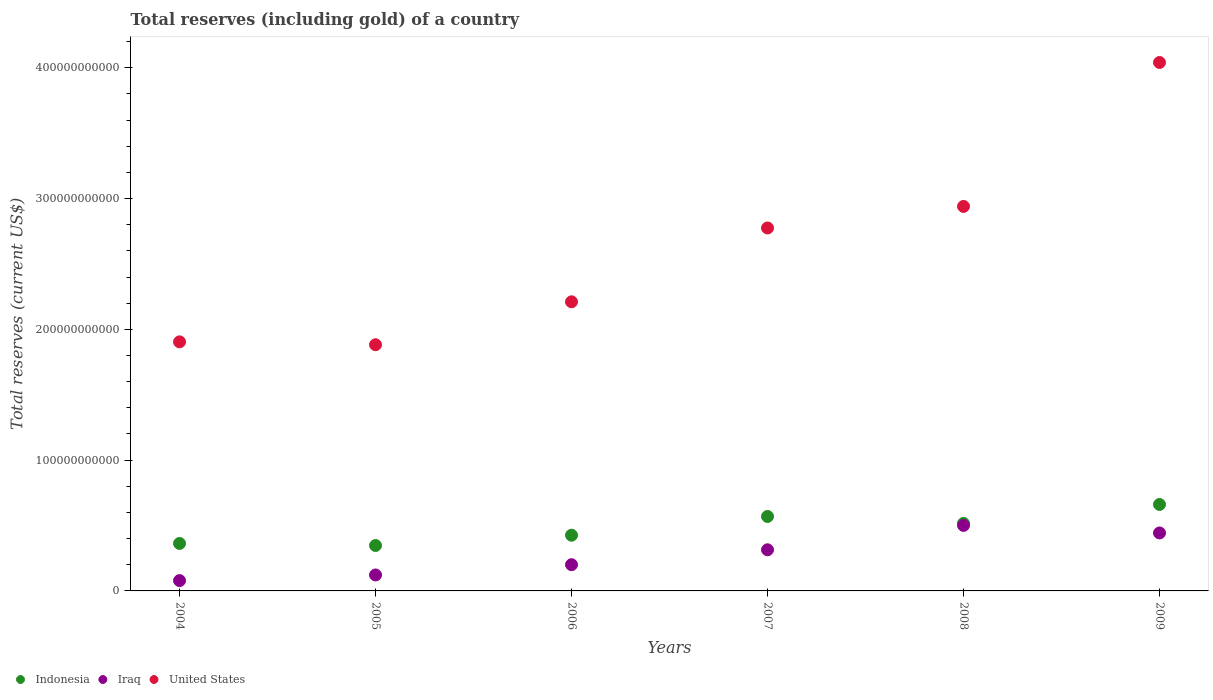Is the number of dotlines equal to the number of legend labels?
Provide a short and direct response. Yes. What is the total reserves (including gold) in Iraq in 2009?
Provide a short and direct response. 4.43e+1. Across all years, what is the maximum total reserves (including gold) in Indonesia?
Provide a succinct answer. 6.61e+1. Across all years, what is the minimum total reserves (including gold) in Indonesia?
Provide a succinct answer. 3.47e+1. What is the total total reserves (including gold) in Iraq in the graph?
Ensure brevity in your answer.  1.66e+11. What is the difference between the total reserves (including gold) in Iraq in 2005 and that in 2007?
Your response must be concise. -1.93e+1. What is the difference between the total reserves (including gold) in Iraq in 2004 and the total reserves (including gold) in United States in 2007?
Offer a terse response. -2.70e+11. What is the average total reserves (including gold) in United States per year?
Provide a short and direct response. 2.63e+11. In the year 2006, what is the difference between the total reserves (including gold) in United States and total reserves (including gold) in Indonesia?
Offer a very short reply. 1.78e+11. What is the ratio of the total reserves (including gold) in United States in 2006 to that in 2008?
Your answer should be compact. 0.75. Is the total reserves (including gold) in Iraq in 2006 less than that in 2008?
Provide a succinct answer. Yes. Is the difference between the total reserves (including gold) in United States in 2004 and 2008 greater than the difference between the total reserves (including gold) in Indonesia in 2004 and 2008?
Your answer should be very brief. No. What is the difference between the highest and the second highest total reserves (including gold) in Indonesia?
Offer a terse response. 9.18e+09. What is the difference between the highest and the lowest total reserves (including gold) in Indonesia?
Your answer should be compact. 3.14e+1. How many dotlines are there?
Your answer should be very brief. 3. What is the difference between two consecutive major ticks on the Y-axis?
Provide a succinct answer. 1.00e+11. Are the values on the major ticks of Y-axis written in scientific E-notation?
Offer a very short reply. No. Does the graph contain grids?
Provide a short and direct response. No. How many legend labels are there?
Provide a short and direct response. 3. How are the legend labels stacked?
Your response must be concise. Horizontal. What is the title of the graph?
Make the answer very short. Total reserves (including gold) of a country. Does "High income: nonOECD" appear as one of the legend labels in the graph?
Offer a terse response. No. What is the label or title of the Y-axis?
Ensure brevity in your answer.  Total reserves (current US$). What is the Total reserves (current US$) in Indonesia in 2004?
Your answer should be compact. 3.63e+1. What is the Total reserves (current US$) in Iraq in 2004?
Ensure brevity in your answer.  7.91e+09. What is the Total reserves (current US$) of United States in 2004?
Offer a terse response. 1.90e+11. What is the Total reserves (current US$) in Indonesia in 2005?
Your answer should be compact. 3.47e+1. What is the Total reserves (current US$) in Iraq in 2005?
Your response must be concise. 1.22e+1. What is the Total reserves (current US$) of United States in 2005?
Keep it short and to the point. 1.88e+11. What is the Total reserves (current US$) of Indonesia in 2006?
Your answer should be very brief. 4.26e+1. What is the Total reserves (current US$) in Iraq in 2006?
Your answer should be compact. 2.01e+1. What is the Total reserves (current US$) in United States in 2006?
Give a very brief answer. 2.21e+11. What is the Total reserves (current US$) in Indonesia in 2007?
Your answer should be compact. 5.69e+1. What is the Total reserves (current US$) in Iraq in 2007?
Provide a succinct answer. 3.15e+1. What is the Total reserves (current US$) in United States in 2007?
Your answer should be compact. 2.78e+11. What is the Total reserves (current US$) of Indonesia in 2008?
Keep it short and to the point. 5.16e+1. What is the Total reserves (current US$) in Iraq in 2008?
Your answer should be very brief. 5.01e+1. What is the Total reserves (current US$) in United States in 2008?
Your answer should be very brief. 2.94e+11. What is the Total reserves (current US$) of Indonesia in 2009?
Provide a succinct answer. 6.61e+1. What is the Total reserves (current US$) of Iraq in 2009?
Keep it short and to the point. 4.43e+1. What is the Total reserves (current US$) of United States in 2009?
Your answer should be very brief. 4.04e+11. Across all years, what is the maximum Total reserves (current US$) in Indonesia?
Your answer should be compact. 6.61e+1. Across all years, what is the maximum Total reserves (current US$) in Iraq?
Your answer should be compact. 5.01e+1. Across all years, what is the maximum Total reserves (current US$) of United States?
Your response must be concise. 4.04e+11. Across all years, what is the minimum Total reserves (current US$) of Indonesia?
Make the answer very short. 3.47e+1. Across all years, what is the minimum Total reserves (current US$) in Iraq?
Make the answer very short. 7.91e+09. Across all years, what is the minimum Total reserves (current US$) of United States?
Your answer should be compact. 1.88e+11. What is the total Total reserves (current US$) in Indonesia in the graph?
Your response must be concise. 2.88e+11. What is the total Total reserves (current US$) in Iraq in the graph?
Your answer should be very brief. 1.66e+11. What is the total Total reserves (current US$) in United States in the graph?
Keep it short and to the point. 1.58e+12. What is the difference between the Total reserves (current US$) of Indonesia in 2004 and that in 2005?
Your answer should be very brief. 1.58e+09. What is the difference between the Total reserves (current US$) in Iraq in 2004 and that in 2005?
Your response must be concise. -4.29e+09. What is the difference between the Total reserves (current US$) in United States in 2004 and that in 2005?
Provide a succinct answer. 2.21e+09. What is the difference between the Total reserves (current US$) of Indonesia in 2004 and that in 2006?
Give a very brief answer. -6.29e+09. What is the difference between the Total reserves (current US$) of Iraq in 2004 and that in 2006?
Make the answer very short. -1.21e+1. What is the difference between the Total reserves (current US$) of United States in 2004 and that in 2006?
Your response must be concise. -3.06e+1. What is the difference between the Total reserves (current US$) of Indonesia in 2004 and that in 2007?
Your response must be concise. -2.06e+1. What is the difference between the Total reserves (current US$) in Iraq in 2004 and that in 2007?
Your answer should be compact. -2.35e+1. What is the difference between the Total reserves (current US$) of United States in 2004 and that in 2007?
Provide a short and direct response. -8.71e+1. What is the difference between the Total reserves (current US$) of Indonesia in 2004 and that in 2008?
Your response must be concise. -1.53e+1. What is the difference between the Total reserves (current US$) in Iraq in 2004 and that in 2008?
Keep it short and to the point. -4.22e+1. What is the difference between the Total reserves (current US$) of United States in 2004 and that in 2008?
Provide a succinct answer. -1.04e+11. What is the difference between the Total reserves (current US$) of Indonesia in 2004 and that in 2009?
Your response must be concise. -2.98e+1. What is the difference between the Total reserves (current US$) of Iraq in 2004 and that in 2009?
Provide a succinct answer. -3.64e+1. What is the difference between the Total reserves (current US$) of United States in 2004 and that in 2009?
Provide a succinct answer. -2.14e+11. What is the difference between the Total reserves (current US$) in Indonesia in 2005 and that in 2006?
Provide a short and direct response. -7.87e+09. What is the difference between the Total reserves (current US$) of Iraq in 2005 and that in 2006?
Provide a succinct answer. -7.85e+09. What is the difference between the Total reserves (current US$) in United States in 2005 and that in 2006?
Make the answer very short. -3.28e+1. What is the difference between the Total reserves (current US$) of Indonesia in 2005 and that in 2007?
Offer a terse response. -2.22e+1. What is the difference between the Total reserves (current US$) in Iraq in 2005 and that in 2007?
Offer a terse response. -1.93e+1. What is the difference between the Total reserves (current US$) in United States in 2005 and that in 2007?
Give a very brief answer. -8.93e+1. What is the difference between the Total reserves (current US$) in Indonesia in 2005 and that in 2008?
Ensure brevity in your answer.  -1.69e+1. What is the difference between the Total reserves (current US$) of Iraq in 2005 and that in 2008?
Provide a succinct answer. -3.79e+1. What is the difference between the Total reserves (current US$) of United States in 2005 and that in 2008?
Ensure brevity in your answer.  -1.06e+11. What is the difference between the Total reserves (current US$) in Indonesia in 2005 and that in 2009?
Provide a succinct answer. -3.14e+1. What is the difference between the Total reserves (current US$) of Iraq in 2005 and that in 2009?
Your answer should be very brief. -3.21e+1. What is the difference between the Total reserves (current US$) of United States in 2005 and that in 2009?
Your response must be concise. -2.16e+11. What is the difference between the Total reserves (current US$) of Indonesia in 2006 and that in 2007?
Your answer should be compact. -1.43e+1. What is the difference between the Total reserves (current US$) of Iraq in 2006 and that in 2007?
Provide a succinct answer. -1.14e+1. What is the difference between the Total reserves (current US$) in United States in 2006 and that in 2007?
Your response must be concise. -5.65e+1. What is the difference between the Total reserves (current US$) in Indonesia in 2006 and that in 2008?
Provide a short and direct response. -9.04e+09. What is the difference between the Total reserves (current US$) of Iraq in 2006 and that in 2008?
Keep it short and to the point. -3.01e+1. What is the difference between the Total reserves (current US$) of United States in 2006 and that in 2008?
Your answer should be compact. -7.30e+1. What is the difference between the Total reserves (current US$) of Indonesia in 2006 and that in 2009?
Offer a very short reply. -2.35e+1. What is the difference between the Total reserves (current US$) in Iraq in 2006 and that in 2009?
Keep it short and to the point. -2.43e+1. What is the difference between the Total reserves (current US$) in United States in 2006 and that in 2009?
Keep it short and to the point. -1.83e+11. What is the difference between the Total reserves (current US$) in Indonesia in 2007 and that in 2008?
Ensure brevity in your answer.  5.30e+09. What is the difference between the Total reserves (current US$) of Iraq in 2007 and that in 2008?
Your answer should be compact. -1.86e+1. What is the difference between the Total reserves (current US$) of United States in 2007 and that in 2008?
Offer a terse response. -1.65e+1. What is the difference between the Total reserves (current US$) in Indonesia in 2007 and that in 2009?
Provide a succinct answer. -9.18e+09. What is the difference between the Total reserves (current US$) of Iraq in 2007 and that in 2009?
Keep it short and to the point. -1.29e+1. What is the difference between the Total reserves (current US$) of United States in 2007 and that in 2009?
Offer a very short reply. -1.27e+11. What is the difference between the Total reserves (current US$) of Indonesia in 2008 and that in 2009?
Your answer should be compact. -1.45e+1. What is the difference between the Total reserves (current US$) in Iraq in 2008 and that in 2009?
Offer a very short reply. 5.77e+09. What is the difference between the Total reserves (current US$) in United States in 2008 and that in 2009?
Keep it short and to the point. -1.10e+11. What is the difference between the Total reserves (current US$) in Indonesia in 2004 and the Total reserves (current US$) in Iraq in 2005?
Ensure brevity in your answer.  2.41e+1. What is the difference between the Total reserves (current US$) in Indonesia in 2004 and the Total reserves (current US$) in United States in 2005?
Offer a terse response. -1.52e+11. What is the difference between the Total reserves (current US$) in Iraq in 2004 and the Total reserves (current US$) in United States in 2005?
Ensure brevity in your answer.  -1.80e+11. What is the difference between the Total reserves (current US$) in Indonesia in 2004 and the Total reserves (current US$) in Iraq in 2006?
Ensure brevity in your answer.  1.63e+1. What is the difference between the Total reserves (current US$) in Indonesia in 2004 and the Total reserves (current US$) in United States in 2006?
Your response must be concise. -1.85e+11. What is the difference between the Total reserves (current US$) in Iraq in 2004 and the Total reserves (current US$) in United States in 2006?
Provide a succinct answer. -2.13e+11. What is the difference between the Total reserves (current US$) of Indonesia in 2004 and the Total reserves (current US$) of Iraq in 2007?
Keep it short and to the point. 4.86e+09. What is the difference between the Total reserves (current US$) of Indonesia in 2004 and the Total reserves (current US$) of United States in 2007?
Provide a short and direct response. -2.41e+11. What is the difference between the Total reserves (current US$) in Iraq in 2004 and the Total reserves (current US$) in United States in 2007?
Your response must be concise. -2.70e+11. What is the difference between the Total reserves (current US$) in Indonesia in 2004 and the Total reserves (current US$) in Iraq in 2008?
Ensure brevity in your answer.  -1.38e+1. What is the difference between the Total reserves (current US$) of Indonesia in 2004 and the Total reserves (current US$) of United States in 2008?
Make the answer very short. -2.58e+11. What is the difference between the Total reserves (current US$) in Iraq in 2004 and the Total reserves (current US$) in United States in 2008?
Provide a succinct answer. -2.86e+11. What is the difference between the Total reserves (current US$) of Indonesia in 2004 and the Total reserves (current US$) of Iraq in 2009?
Your response must be concise. -8.02e+09. What is the difference between the Total reserves (current US$) of Indonesia in 2004 and the Total reserves (current US$) of United States in 2009?
Make the answer very short. -3.68e+11. What is the difference between the Total reserves (current US$) in Iraq in 2004 and the Total reserves (current US$) in United States in 2009?
Your response must be concise. -3.96e+11. What is the difference between the Total reserves (current US$) of Indonesia in 2005 and the Total reserves (current US$) of Iraq in 2006?
Give a very brief answer. 1.47e+1. What is the difference between the Total reserves (current US$) of Indonesia in 2005 and the Total reserves (current US$) of United States in 2006?
Offer a terse response. -1.86e+11. What is the difference between the Total reserves (current US$) of Iraq in 2005 and the Total reserves (current US$) of United States in 2006?
Give a very brief answer. -2.09e+11. What is the difference between the Total reserves (current US$) of Indonesia in 2005 and the Total reserves (current US$) of Iraq in 2007?
Provide a short and direct response. 3.28e+09. What is the difference between the Total reserves (current US$) of Indonesia in 2005 and the Total reserves (current US$) of United States in 2007?
Give a very brief answer. -2.43e+11. What is the difference between the Total reserves (current US$) in Iraq in 2005 and the Total reserves (current US$) in United States in 2007?
Make the answer very short. -2.65e+11. What is the difference between the Total reserves (current US$) in Indonesia in 2005 and the Total reserves (current US$) in Iraq in 2008?
Make the answer very short. -1.54e+1. What is the difference between the Total reserves (current US$) in Indonesia in 2005 and the Total reserves (current US$) in United States in 2008?
Your response must be concise. -2.59e+11. What is the difference between the Total reserves (current US$) in Iraq in 2005 and the Total reserves (current US$) in United States in 2008?
Give a very brief answer. -2.82e+11. What is the difference between the Total reserves (current US$) in Indonesia in 2005 and the Total reserves (current US$) in Iraq in 2009?
Keep it short and to the point. -9.60e+09. What is the difference between the Total reserves (current US$) of Indonesia in 2005 and the Total reserves (current US$) of United States in 2009?
Your answer should be compact. -3.69e+11. What is the difference between the Total reserves (current US$) in Iraq in 2005 and the Total reserves (current US$) in United States in 2009?
Offer a terse response. -3.92e+11. What is the difference between the Total reserves (current US$) of Indonesia in 2006 and the Total reserves (current US$) of Iraq in 2007?
Offer a very short reply. 1.11e+1. What is the difference between the Total reserves (current US$) of Indonesia in 2006 and the Total reserves (current US$) of United States in 2007?
Offer a very short reply. -2.35e+11. What is the difference between the Total reserves (current US$) of Iraq in 2006 and the Total reserves (current US$) of United States in 2007?
Provide a succinct answer. -2.57e+11. What is the difference between the Total reserves (current US$) in Indonesia in 2006 and the Total reserves (current US$) in Iraq in 2008?
Ensure brevity in your answer.  -7.50e+09. What is the difference between the Total reserves (current US$) of Indonesia in 2006 and the Total reserves (current US$) of United States in 2008?
Provide a succinct answer. -2.51e+11. What is the difference between the Total reserves (current US$) of Iraq in 2006 and the Total reserves (current US$) of United States in 2008?
Make the answer very short. -2.74e+11. What is the difference between the Total reserves (current US$) of Indonesia in 2006 and the Total reserves (current US$) of Iraq in 2009?
Ensure brevity in your answer.  -1.74e+09. What is the difference between the Total reserves (current US$) in Indonesia in 2006 and the Total reserves (current US$) in United States in 2009?
Your answer should be compact. -3.62e+11. What is the difference between the Total reserves (current US$) in Iraq in 2006 and the Total reserves (current US$) in United States in 2009?
Your answer should be very brief. -3.84e+11. What is the difference between the Total reserves (current US$) of Indonesia in 2007 and the Total reserves (current US$) of Iraq in 2008?
Keep it short and to the point. 6.83e+09. What is the difference between the Total reserves (current US$) of Indonesia in 2007 and the Total reserves (current US$) of United States in 2008?
Your answer should be very brief. -2.37e+11. What is the difference between the Total reserves (current US$) in Iraq in 2007 and the Total reserves (current US$) in United States in 2008?
Your answer should be compact. -2.63e+11. What is the difference between the Total reserves (current US$) of Indonesia in 2007 and the Total reserves (current US$) of Iraq in 2009?
Your answer should be very brief. 1.26e+1. What is the difference between the Total reserves (current US$) in Indonesia in 2007 and the Total reserves (current US$) in United States in 2009?
Ensure brevity in your answer.  -3.47e+11. What is the difference between the Total reserves (current US$) of Iraq in 2007 and the Total reserves (current US$) of United States in 2009?
Offer a very short reply. -3.73e+11. What is the difference between the Total reserves (current US$) of Indonesia in 2008 and the Total reserves (current US$) of Iraq in 2009?
Provide a succinct answer. 7.31e+09. What is the difference between the Total reserves (current US$) of Indonesia in 2008 and the Total reserves (current US$) of United States in 2009?
Your answer should be compact. -3.52e+11. What is the difference between the Total reserves (current US$) of Iraq in 2008 and the Total reserves (current US$) of United States in 2009?
Your response must be concise. -3.54e+11. What is the average Total reserves (current US$) in Indonesia per year?
Ensure brevity in your answer.  4.81e+1. What is the average Total reserves (current US$) in Iraq per year?
Give a very brief answer. 2.77e+1. What is the average Total reserves (current US$) of United States per year?
Offer a terse response. 2.63e+11. In the year 2004, what is the difference between the Total reserves (current US$) of Indonesia and Total reserves (current US$) of Iraq?
Offer a terse response. 2.84e+1. In the year 2004, what is the difference between the Total reserves (current US$) in Indonesia and Total reserves (current US$) in United States?
Keep it short and to the point. -1.54e+11. In the year 2004, what is the difference between the Total reserves (current US$) in Iraq and Total reserves (current US$) in United States?
Make the answer very short. -1.83e+11. In the year 2005, what is the difference between the Total reserves (current US$) in Indonesia and Total reserves (current US$) in Iraq?
Your answer should be very brief. 2.25e+1. In the year 2005, what is the difference between the Total reserves (current US$) of Indonesia and Total reserves (current US$) of United States?
Provide a short and direct response. -1.54e+11. In the year 2005, what is the difference between the Total reserves (current US$) in Iraq and Total reserves (current US$) in United States?
Make the answer very short. -1.76e+11. In the year 2006, what is the difference between the Total reserves (current US$) of Indonesia and Total reserves (current US$) of Iraq?
Give a very brief answer. 2.25e+1. In the year 2006, what is the difference between the Total reserves (current US$) in Indonesia and Total reserves (current US$) in United States?
Ensure brevity in your answer.  -1.78e+11. In the year 2006, what is the difference between the Total reserves (current US$) of Iraq and Total reserves (current US$) of United States?
Make the answer very short. -2.01e+11. In the year 2007, what is the difference between the Total reserves (current US$) in Indonesia and Total reserves (current US$) in Iraq?
Your answer should be very brief. 2.55e+1. In the year 2007, what is the difference between the Total reserves (current US$) of Indonesia and Total reserves (current US$) of United States?
Provide a succinct answer. -2.21e+11. In the year 2007, what is the difference between the Total reserves (current US$) in Iraq and Total reserves (current US$) in United States?
Give a very brief answer. -2.46e+11. In the year 2008, what is the difference between the Total reserves (current US$) in Indonesia and Total reserves (current US$) in Iraq?
Your answer should be very brief. 1.54e+09. In the year 2008, what is the difference between the Total reserves (current US$) of Indonesia and Total reserves (current US$) of United States?
Give a very brief answer. -2.42e+11. In the year 2008, what is the difference between the Total reserves (current US$) of Iraq and Total reserves (current US$) of United States?
Provide a succinct answer. -2.44e+11. In the year 2009, what is the difference between the Total reserves (current US$) in Indonesia and Total reserves (current US$) in Iraq?
Your answer should be very brief. 2.18e+1. In the year 2009, what is the difference between the Total reserves (current US$) in Indonesia and Total reserves (current US$) in United States?
Ensure brevity in your answer.  -3.38e+11. In the year 2009, what is the difference between the Total reserves (current US$) of Iraq and Total reserves (current US$) of United States?
Keep it short and to the point. -3.60e+11. What is the ratio of the Total reserves (current US$) in Indonesia in 2004 to that in 2005?
Your answer should be compact. 1.05. What is the ratio of the Total reserves (current US$) of Iraq in 2004 to that in 2005?
Give a very brief answer. 0.65. What is the ratio of the Total reserves (current US$) of United States in 2004 to that in 2005?
Your answer should be very brief. 1.01. What is the ratio of the Total reserves (current US$) in Indonesia in 2004 to that in 2006?
Make the answer very short. 0.85. What is the ratio of the Total reserves (current US$) of Iraq in 2004 to that in 2006?
Your response must be concise. 0.39. What is the ratio of the Total reserves (current US$) in United States in 2004 to that in 2006?
Provide a succinct answer. 0.86. What is the ratio of the Total reserves (current US$) in Indonesia in 2004 to that in 2007?
Make the answer very short. 0.64. What is the ratio of the Total reserves (current US$) of Iraq in 2004 to that in 2007?
Your answer should be very brief. 0.25. What is the ratio of the Total reserves (current US$) in United States in 2004 to that in 2007?
Your answer should be compact. 0.69. What is the ratio of the Total reserves (current US$) in Indonesia in 2004 to that in 2008?
Your answer should be compact. 0.7. What is the ratio of the Total reserves (current US$) of Iraq in 2004 to that in 2008?
Your answer should be compact. 0.16. What is the ratio of the Total reserves (current US$) in United States in 2004 to that in 2008?
Your response must be concise. 0.65. What is the ratio of the Total reserves (current US$) of Indonesia in 2004 to that in 2009?
Your response must be concise. 0.55. What is the ratio of the Total reserves (current US$) in Iraq in 2004 to that in 2009?
Provide a short and direct response. 0.18. What is the ratio of the Total reserves (current US$) in United States in 2004 to that in 2009?
Ensure brevity in your answer.  0.47. What is the ratio of the Total reserves (current US$) of Indonesia in 2005 to that in 2006?
Offer a very short reply. 0.82. What is the ratio of the Total reserves (current US$) of Iraq in 2005 to that in 2006?
Provide a short and direct response. 0.61. What is the ratio of the Total reserves (current US$) in United States in 2005 to that in 2006?
Offer a terse response. 0.85. What is the ratio of the Total reserves (current US$) of Indonesia in 2005 to that in 2007?
Offer a very short reply. 0.61. What is the ratio of the Total reserves (current US$) of Iraq in 2005 to that in 2007?
Offer a very short reply. 0.39. What is the ratio of the Total reserves (current US$) in United States in 2005 to that in 2007?
Offer a terse response. 0.68. What is the ratio of the Total reserves (current US$) in Indonesia in 2005 to that in 2008?
Provide a short and direct response. 0.67. What is the ratio of the Total reserves (current US$) of Iraq in 2005 to that in 2008?
Your response must be concise. 0.24. What is the ratio of the Total reserves (current US$) of United States in 2005 to that in 2008?
Your answer should be very brief. 0.64. What is the ratio of the Total reserves (current US$) of Indonesia in 2005 to that in 2009?
Provide a succinct answer. 0.53. What is the ratio of the Total reserves (current US$) in Iraq in 2005 to that in 2009?
Offer a very short reply. 0.28. What is the ratio of the Total reserves (current US$) of United States in 2005 to that in 2009?
Offer a terse response. 0.47. What is the ratio of the Total reserves (current US$) in Indonesia in 2006 to that in 2007?
Offer a very short reply. 0.75. What is the ratio of the Total reserves (current US$) of Iraq in 2006 to that in 2007?
Ensure brevity in your answer.  0.64. What is the ratio of the Total reserves (current US$) of United States in 2006 to that in 2007?
Offer a very short reply. 0.8. What is the ratio of the Total reserves (current US$) in Indonesia in 2006 to that in 2008?
Keep it short and to the point. 0.82. What is the ratio of the Total reserves (current US$) in Iraq in 2006 to that in 2008?
Provide a short and direct response. 0.4. What is the ratio of the Total reserves (current US$) of United States in 2006 to that in 2008?
Provide a short and direct response. 0.75. What is the ratio of the Total reserves (current US$) of Indonesia in 2006 to that in 2009?
Your answer should be very brief. 0.64. What is the ratio of the Total reserves (current US$) of Iraq in 2006 to that in 2009?
Offer a very short reply. 0.45. What is the ratio of the Total reserves (current US$) of United States in 2006 to that in 2009?
Ensure brevity in your answer.  0.55. What is the ratio of the Total reserves (current US$) in Indonesia in 2007 to that in 2008?
Provide a succinct answer. 1.1. What is the ratio of the Total reserves (current US$) in Iraq in 2007 to that in 2008?
Your answer should be compact. 0.63. What is the ratio of the Total reserves (current US$) in United States in 2007 to that in 2008?
Give a very brief answer. 0.94. What is the ratio of the Total reserves (current US$) in Indonesia in 2007 to that in 2009?
Your answer should be compact. 0.86. What is the ratio of the Total reserves (current US$) in Iraq in 2007 to that in 2009?
Your response must be concise. 0.71. What is the ratio of the Total reserves (current US$) of United States in 2007 to that in 2009?
Provide a short and direct response. 0.69. What is the ratio of the Total reserves (current US$) in Indonesia in 2008 to that in 2009?
Give a very brief answer. 0.78. What is the ratio of the Total reserves (current US$) of Iraq in 2008 to that in 2009?
Make the answer very short. 1.13. What is the ratio of the Total reserves (current US$) in United States in 2008 to that in 2009?
Make the answer very short. 0.73. What is the difference between the highest and the second highest Total reserves (current US$) of Indonesia?
Ensure brevity in your answer.  9.18e+09. What is the difference between the highest and the second highest Total reserves (current US$) of Iraq?
Your answer should be compact. 5.77e+09. What is the difference between the highest and the second highest Total reserves (current US$) in United States?
Offer a terse response. 1.10e+11. What is the difference between the highest and the lowest Total reserves (current US$) in Indonesia?
Ensure brevity in your answer.  3.14e+1. What is the difference between the highest and the lowest Total reserves (current US$) of Iraq?
Your answer should be compact. 4.22e+1. What is the difference between the highest and the lowest Total reserves (current US$) of United States?
Ensure brevity in your answer.  2.16e+11. 